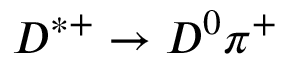Convert formula to latex. <formula><loc_0><loc_0><loc_500><loc_500>D ^ { * + } \to D ^ { 0 } \pi ^ { + }</formula> 